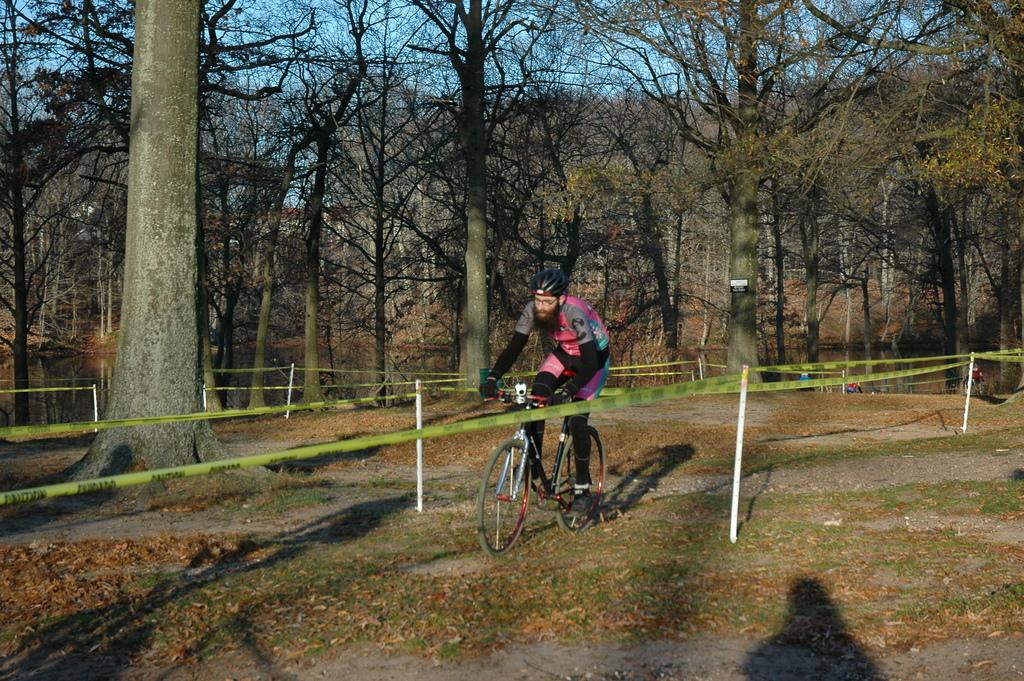What is the main subject of the image? There is a person riding a bicycle in the image. What can be seen in the background of the image? There are white poles, dried trees, and green trees in the background of the image. What is the color of the sky in the image? The sky is blue in the image. What type of can is being used by the person riding the bicycle? There is no can present in the image. 